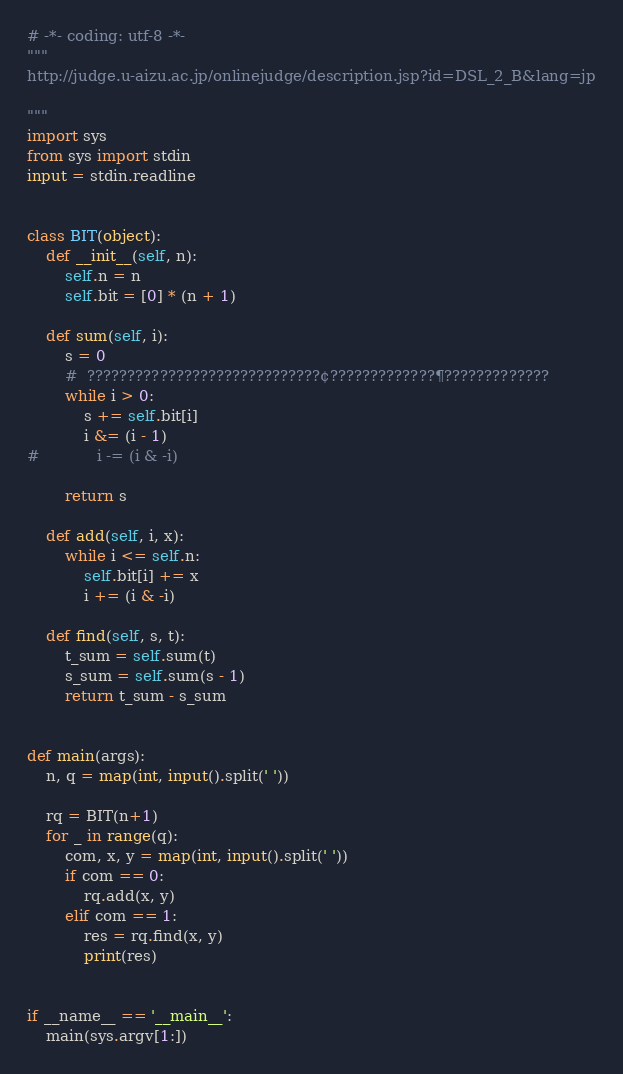Convert code to text. <code><loc_0><loc_0><loc_500><loc_500><_Python_># -*- coding: utf-8 -*-
"""
http://judge.u-aizu.ac.jp/onlinejudge/description.jsp?id=DSL_2_B&lang=jp

"""
import sys
from sys import stdin
input = stdin.readline


class BIT(object):
    def __init__(self, n):
        self.n = n
        self.bit = [0] * (n + 1)

    def sum(self, i):
        s = 0
        #  ?????????????????????????????¢?????????????¶?????????????
        while i > 0:
            s += self.bit[i]
            i &= (i - 1)
#            i -= (i & -i)

        return s

    def add(self, i, x):
        while i <= self.n:
            self.bit[i] += x
            i += (i & -i)

    def find(self, s, t):
        t_sum = self.sum(t)
        s_sum = self.sum(s - 1)
        return t_sum - s_sum


def main(args):
    n, q = map(int, input().split(' '))

    rq = BIT(n+1)
    for _ in range(q):
        com, x, y = map(int, input().split(' '))
        if com == 0:
            rq.add(x, y)
        elif com == 1:
            res = rq.find(x, y)
            print(res)


if __name__ == '__main__':
    main(sys.argv[1:])</code> 